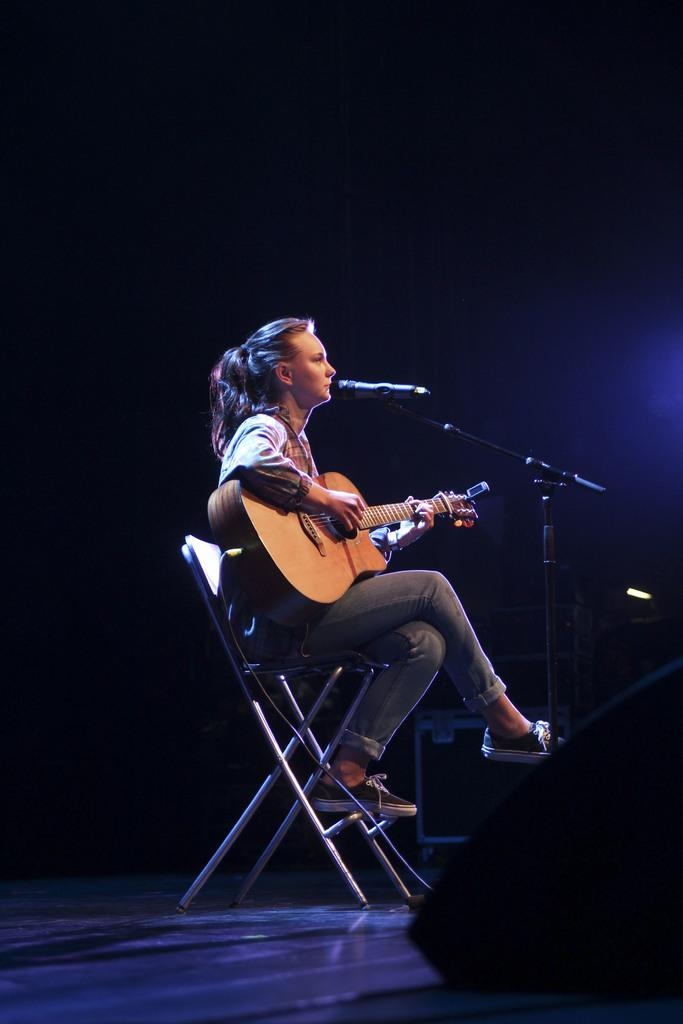Who is the main subject in the image? There is a woman in the image. What is the woman doing in the image? The woman is sitting in a chair and playing a guitar. What object is in front of the woman? There is a microphone in front of the woman. What type of card is the woman holding in the image? There is no card present in the image; the woman is playing a guitar and there is a microphone in front of her. 